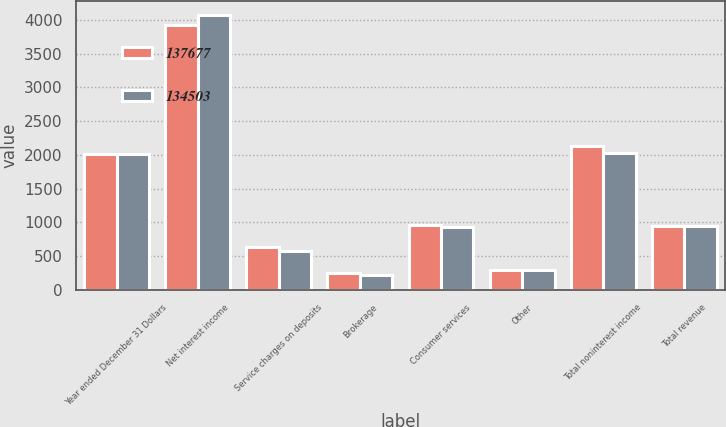<chart> <loc_0><loc_0><loc_500><loc_500><stacked_bar_chart><ecel><fcel>Year ended December 31 Dollars<fcel>Net interest income<fcel>Service charges on deposits<fcel>Brokerage<fcel>Consumer services<fcel>Other<fcel>Total noninterest income<fcel>Total revenue<nl><fcel>137677<fcel>2014<fcel>3924<fcel>633<fcel>240<fcel>961<fcel>291<fcel>2125<fcel>948<nl><fcel>134503<fcel>2013<fcel>4079<fcel>570<fcel>224<fcel>935<fcel>292<fcel>2021<fcel>948<nl></chart> 